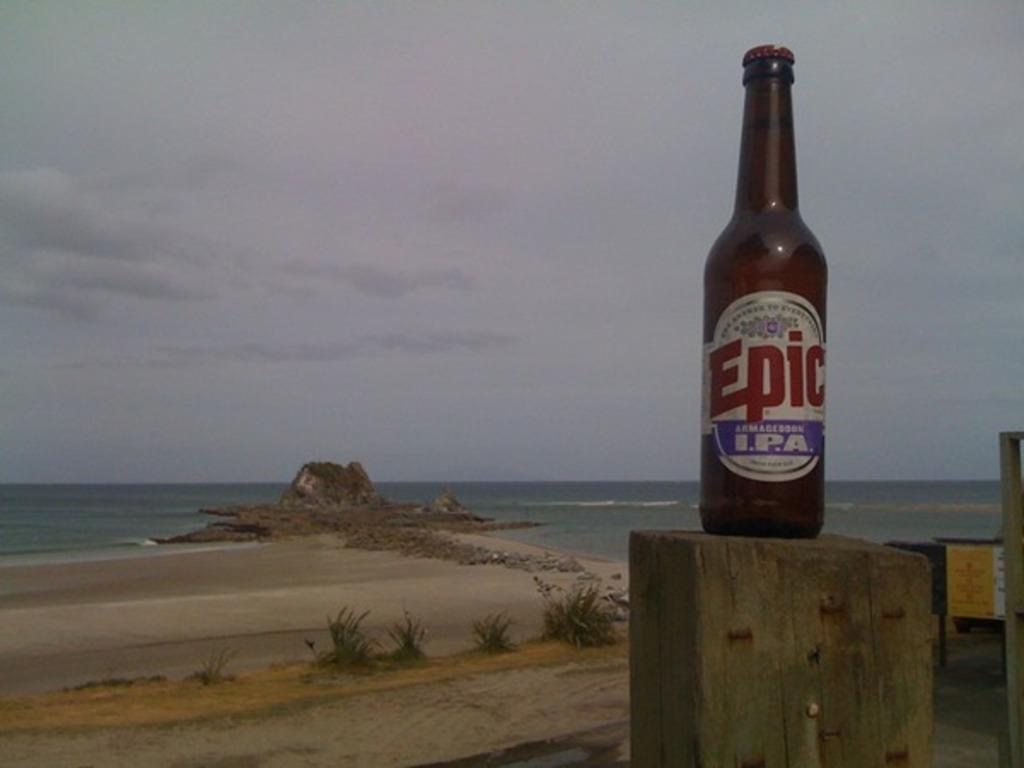<image>
Summarize the visual content of the image. A wooden post with a bottle of Epic ARMAGEDDON I.P.A. with a beach in the background. 